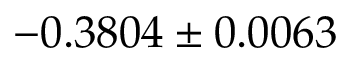<formula> <loc_0><loc_0><loc_500><loc_500>- 0 . 3 8 0 4 \pm 0 . 0 0 6 3</formula> 